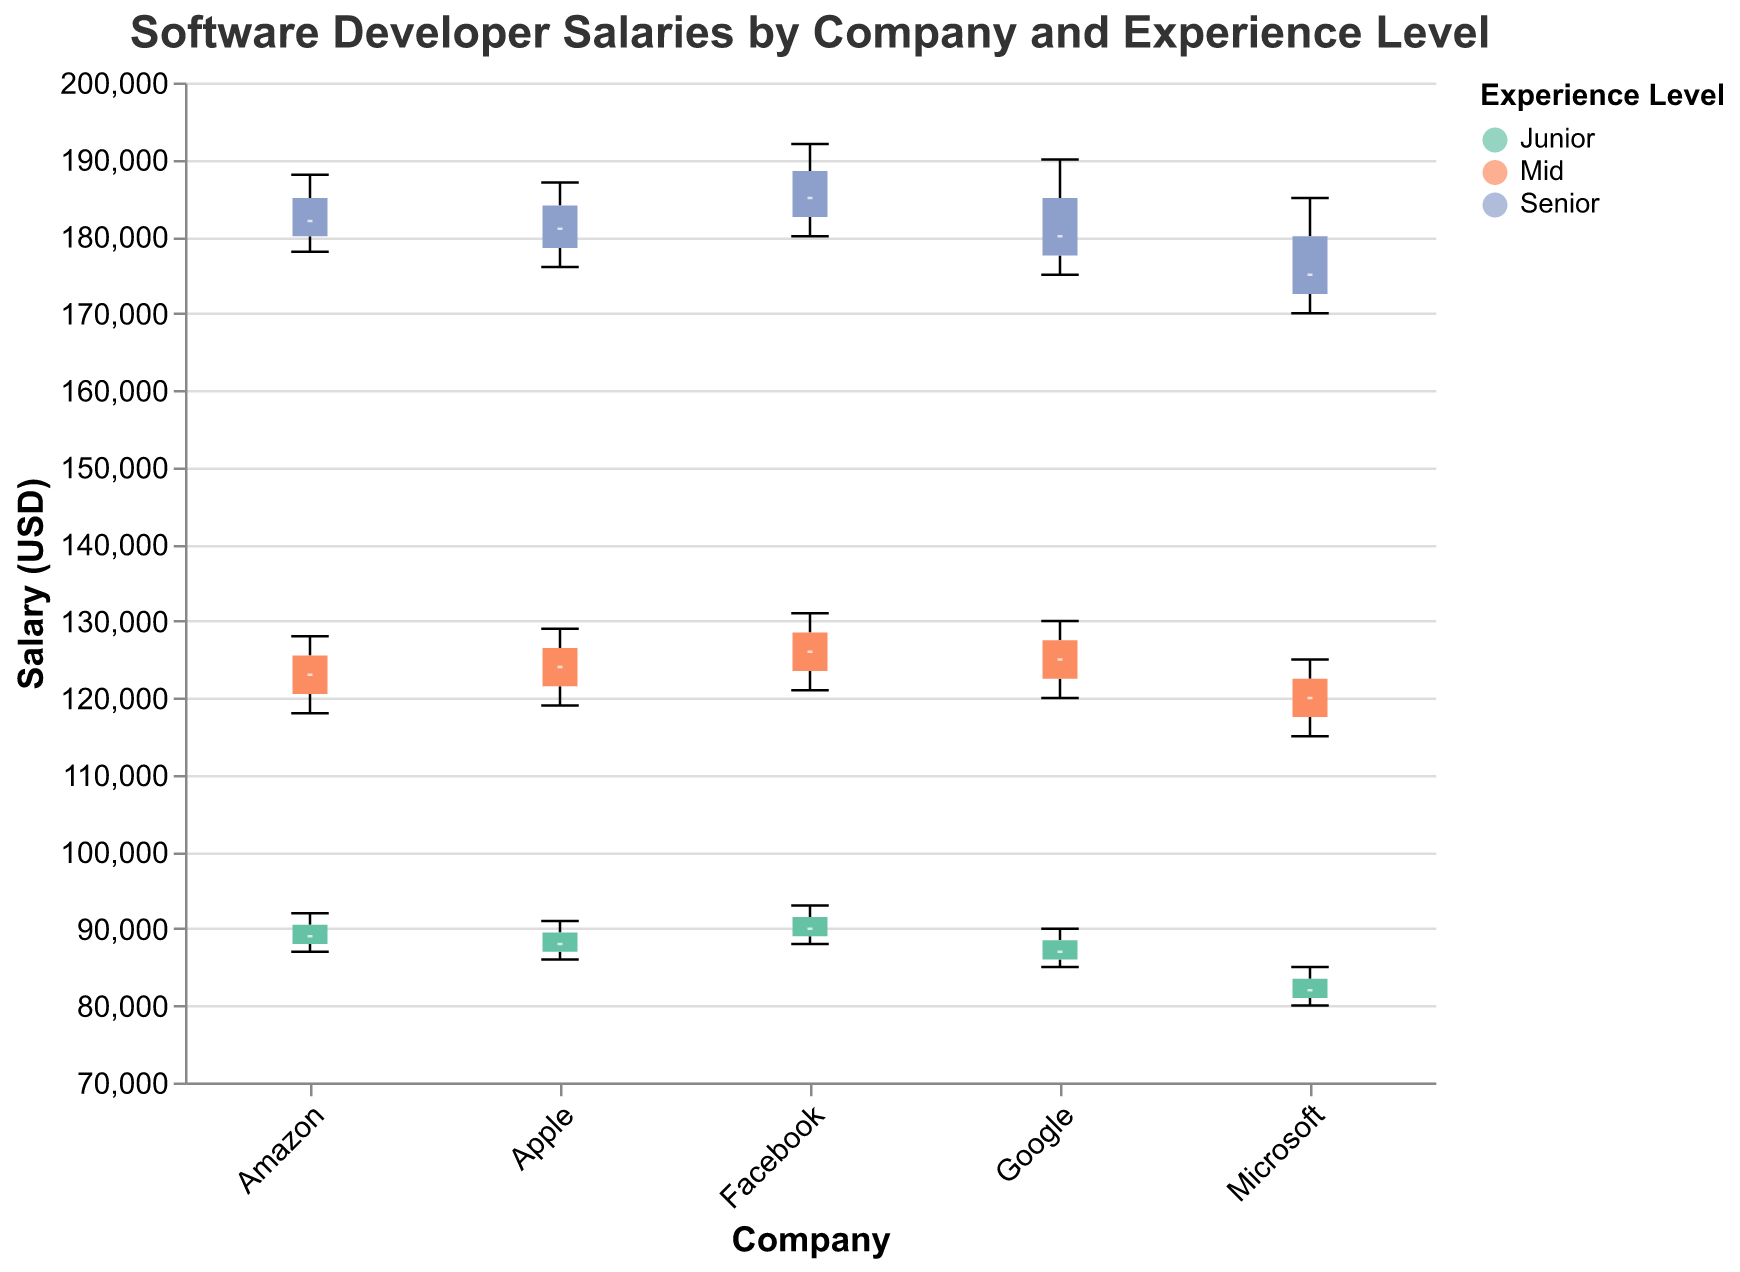What is the median salary for junior developers at Google? The median is indicated by a white line inside the box for each group. For junior developers at Google, this line is at $87,000.
Answer: $87,000 Which company offers the highest median salary for senior developers? The highest median salary is identified by comparing the white lines inside the boxes for the 'Senior' category of each company. Facebook's white line is at $185,000, which is the highest.
Answer: Facebook What is the salary range for mid-level developers at Microsoft? The salary range is the difference between the maximum and minimum values of the box plot for mid-level developers at Microsoft. The range spans from $115,000 to $125,000.
Answer: $10,000 How does the median salary for junior developers at Amazon compare to that at Facebook? Compare the white lines inside the boxes for Amazon and Facebook in the 'Junior' category. Amazon's median is $89,000 and Facebook's is $90,000.
Answer: Less by $1,000 What is the interquartile range (IQR) for senior developers at Apple? The IQR is the difference between the third quartile (upper edge of the box) and the first quartile (lower edge of the box) for the 'Senior' category at Apple. It ranges approximately from $176,000 to $181,000.
Answer: $5,000 Which experience level shows the most variation in salary at Google? Most variation is represented by the length of the whiskers (from min to max values). For Google, the 'Senior' category shows salaries ranging from $175,000 to $190,000.
Answer: Senior Are there any overlapping notches between different experience levels at Facebook? Notches overlap if they have common values within the notches indicating similar medians. At Facebook, the 'Mid' and 'Junior' levels have overlapping notches.
Answer: Yes Is there a significant difference in the median salaries of mid-level developers between Microsoft and Amazon? Compare the white lines (medians) of mid-level developers for Microsoft and Amazon. Microsoft's median is $120,000 while Amazon's is $123,000.
Answer: Yes What's the median difference between junior and senior developers at Apple? Subtract the median salary of 'Junior' developers from 'Senior' developers at Apple. $180,000 (senior) - $87,000 (junior) equals $93,000.
Answer: $93,000 